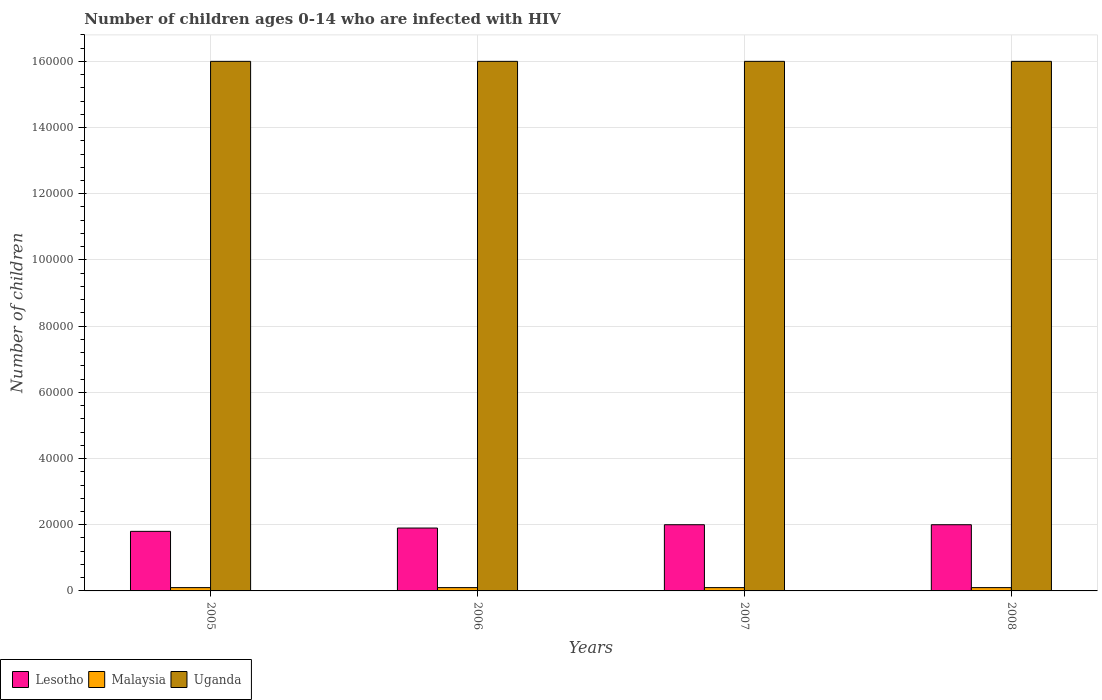How many different coloured bars are there?
Ensure brevity in your answer.  3. Are the number of bars on each tick of the X-axis equal?
Provide a short and direct response. Yes. How many bars are there on the 4th tick from the right?
Offer a very short reply. 3. What is the number of HIV infected children in Lesotho in 2006?
Make the answer very short. 1.90e+04. Across all years, what is the maximum number of HIV infected children in Lesotho?
Offer a terse response. 2.00e+04. Across all years, what is the minimum number of HIV infected children in Malaysia?
Provide a succinct answer. 1000. In which year was the number of HIV infected children in Malaysia minimum?
Your answer should be compact. 2005. What is the total number of HIV infected children in Malaysia in the graph?
Your answer should be very brief. 4000. What is the difference between the number of HIV infected children in Lesotho in 2005 and that in 2007?
Your answer should be compact. -2000. What is the difference between the number of HIV infected children in Malaysia in 2008 and the number of HIV infected children in Uganda in 2006?
Provide a succinct answer. -1.59e+05. In the year 2005, what is the difference between the number of HIV infected children in Malaysia and number of HIV infected children in Lesotho?
Offer a terse response. -1.70e+04. In how many years, is the number of HIV infected children in Uganda greater than 48000?
Offer a very short reply. 4. Is the number of HIV infected children in Lesotho in 2006 less than that in 2007?
Offer a terse response. Yes. Is the difference between the number of HIV infected children in Malaysia in 2005 and 2006 greater than the difference between the number of HIV infected children in Lesotho in 2005 and 2006?
Your response must be concise. Yes. What is the difference between the highest and the second highest number of HIV infected children in Uganda?
Ensure brevity in your answer.  0. What is the difference between the highest and the lowest number of HIV infected children in Malaysia?
Offer a terse response. 0. Is the sum of the number of HIV infected children in Uganda in 2005 and 2008 greater than the maximum number of HIV infected children in Malaysia across all years?
Give a very brief answer. Yes. What does the 2nd bar from the left in 2007 represents?
Provide a short and direct response. Malaysia. What does the 3rd bar from the right in 2008 represents?
Provide a short and direct response. Lesotho. Is it the case that in every year, the sum of the number of HIV infected children in Lesotho and number of HIV infected children in Uganda is greater than the number of HIV infected children in Malaysia?
Offer a terse response. Yes. Are the values on the major ticks of Y-axis written in scientific E-notation?
Your answer should be compact. No. Does the graph contain any zero values?
Provide a short and direct response. No. Where does the legend appear in the graph?
Make the answer very short. Bottom left. What is the title of the graph?
Make the answer very short. Number of children ages 0-14 who are infected with HIV. Does "Belarus" appear as one of the legend labels in the graph?
Keep it short and to the point. No. What is the label or title of the Y-axis?
Offer a very short reply. Number of children. What is the Number of children in Lesotho in 2005?
Your answer should be compact. 1.80e+04. What is the Number of children of Malaysia in 2005?
Keep it short and to the point. 1000. What is the Number of children in Uganda in 2005?
Provide a succinct answer. 1.60e+05. What is the Number of children in Lesotho in 2006?
Provide a succinct answer. 1.90e+04. What is the Number of children in Uganda in 2006?
Give a very brief answer. 1.60e+05. What is the Number of children of Uganda in 2007?
Provide a short and direct response. 1.60e+05. What is the Number of children of Malaysia in 2008?
Give a very brief answer. 1000. Across all years, what is the maximum Number of children of Malaysia?
Offer a terse response. 1000. Across all years, what is the minimum Number of children in Lesotho?
Make the answer very short. 1.80e+04. Across all years, what is the minimum Number of children of Malaysia?
Make the answer very short. 1000. What is the total Number of children in Lesotho in the graph?
Offer a terse response. 7.70e+04. What is the total Number of children in Malaysia in the graph?
Offer a very short reply. 4000. What is the total Number of children of Uganda in the graph?
Your answer should be compact. 6.40e+05. What is the difference between the Number of children of Lesotho in 2005 and that in 2006?
Give a very brief answer. -1000. What is the difference between the Number of children in Malaysia in 2005 and that in 2006?
Keep it short and to the point. 0. What is the difference between the Number of children of Uganda in 2005 and that in 2006?
Make the answer very short. 0. What is the difference between the Number of children in Lesotho in 2005 and that in 2007?
Provide a succinct answer. -2000. What is the difference between the Number of children in Uganda in 2005 and that in 2007?
Your answer should be compact. 0. What is the difference between the Number of children in Lesotho in 2005 and that in 2008?
Give a very brief answer. -2000. What is the difference between the Number of children in Lesotho in 2006 and that in 2007?
Your response must be concise. -1000. What is the difference between the Number of children in Lesotho in 2006 and that in 2008?
Your response must be concise. -1000. What is the difference between the Number of children in Malaysia in 2006 and that in 2008?
Keep it short and to the point. 0. What is the difference between the Number of children in Uganda in 2006 and that in 2008?
Make the answer very short. 0. What is the difference between the Number of children of Lesotho in 2007 and that in 2008?
Provide a succinct answer. 0. What is the difference between the Number of children in Uganda in 2007 and that in 2008?
Offer a very short reply. 0. What is the difference between the Number of children of Lesotho in 2005 and the Number of children of Malaysia in 2006?
Provide a succinct answer. 1.70e+04. What is the difference between the Number of children of Lesotho in 2005 and the Number of children of Uganda in 2006?
Your answer should be compact. -1.42e+05. What is the difference between the Number of children in Malaysia in 2005 and the Number of children in Uganda in 2006?
Offer a very short reply. -1.59e+05. What is the difference between the Number of children of Lesotho in 2005 and the Number of children of Malaysia in 2007?
Offer a very short reply. 1.70e+04. What is the difference between the Number of children in Lesotho in 2005 and the Number of children in Uganda in 2007?
Offer a terse response. -1.42e+05. What is the difference between the Number of children in Malaysia in 2005 and the Number of children in Uganda in 2007?
Make the answer very short. -1.59e+05. What is the difference between the Number of children of Lesotho in 2005 and the Number of children of Malaysia in 2008?
Keep it short and to the point. 1.70e+04. What is the difference between the Number of children of Lesotho in 2005 and the Number of children of Uganda in 2008?
Provide a succinct answer. -1.42e+05. What is the difference between the Number of children in Malaysia in 2005 and the Number of children in Uganda in 2008?
Give a very brief answer. -1.59e+05. What is the difference between the Number of children in Lesotho in 2006 and the Number of children in Malaysia in 2007?
Your response must be concise. 1.80e+04. What is the difference between the Number of children of Lesotho in 2006 and the Number of children of Uganda in 2007?
Ensure brevity in your answer.  -1.41e+05. What is the difference between the Number of children in Malaysia in 2006 and the Number of children in Uganda in 2007?
Your response must be concise. -1.59e+05. What is the difference between the Number of children in Lesotho in 2006 and the Number of children in Malaysia in 2008?
Your response must be concise. 1.80e+04. What is the difference between the Number of children of Lesotho in 2006 and the Number of children of Uganda in 2008?
Give a very brief answer. -1.41e+05. What is the difference between the Number of children of Malaysia in 2006 and the Number of children of Uganda in 2008?
Keep it short and to the point. -1.59e+05. What is the difference between the Number of children in Lesotho in 2007 and the Number of children in Malaysia in 2008?
Offer a terse response. 1.90e+04. What is the difference between the Number of children in Lesotho in 2007 and the Number of children in Uganda in 2008?
Your answer should be compact. -1.40e+05. What is the difference between the Number of children of Malaysia in 2007 and the Number of children of Uganda in 2008?
Ensure brevity in your answer.  -1.59e+05. What is the average Number of children of Lesotho per year?
Your answer should be compact. 1.92e+04. What is the average Number of children of Uganda per year?
Your response must be concise. 1.60e+05. In the year 2005, what is the difference between the Number of children in Lesotho and Number of children in Malaysia?
Your response must be concise. 1.70e+04. In the year 2005, what is the difference between the Number of children in Lesotho and Number of children in Uganda?
Provide a succinct answer. -1.42e+05. In the year 2005, what is the difference between the Number of children of Malaysia and Number of children of Uganda?
Offer a very short reply. -1.59e+05. In the year 2006, what is the difference between the Number of children in Lesotho and Number of children in Malaysia?
Keep it short and to the point. 1.80e+04. In the year 2006, what is the difference between the Number of children in Lesotho and Number of children in Uganda?
Offer a terse response. -1.41e+05. In the year 2006, what is the difference between the Number of children in Malaysia and Number of children in Uganda?
Give a very brief answer. -1.59e+05. In the year 2007, what is the difference between the Number of children of Lesotho and Number of children of Malaysia?
Give a very brief answer. 1.90e+04. In the year 2007, what is the difference between the Number of children in Lesotho and Number of children in Uganda?
Give a very brief answer. -1.40e+05. In the year 2007, what is the difference between the Number of children in Malaysia and Number of children in Uganda?
Make the answer very short. -1.59e+05. In the year 2008, what is the difference between the Number of children in Lesotho and Number of children in Malaysia?
Offer a terse response. 1.90e+04. In the year 2008, what is the difference between the Number of children of Lesotho and Number of children of Uganda?
Ensure brevity in your answer.  -1.40e+05. In the year 2008, what is the difference between the Number of children in Malaysia and Number of children in Uganda?
Keep it short and to the point. -1.59e+05. What is the ratio of the Number of children in Uganda in 2005 to that in 2006?
Offer a terse response. 1. What is the ratio of the Number of children in Uganda in 2005 to that in 2007?
Provide a short and direct response. 1. What is the ratio of the Number of children in Lesotho in 2005 to that in 2008?
Provide a short and direct response. 0.9. What is the ratio of the Number of children in Malaysia in 2005 to that in 2008?
Your answer should be very brief. 1. What is the ratio of the Number of children in Uganda in 2005 to that in 2008?
Your answer should be compact. 1. What is the ratio of the Number of children in Lesotho in 2006 to that in 2007?
Your response must be concise. 0.95. What is the ratio of the Number of children in Malaysia in 2006 to that in 2007?
Your answer should be compact. 1. What is the ratio of the Number of children of Uganda in 2006 to that in 2007?
Ensure brevity in your answer.  1. What is the ratio of the Number of children in Lesotho in 2006 to that in 2008?
Your answer should be very brief. 0.95. What is the ratio of the Number of children in Malaysia in 2006 to that in 2008?
Your response must be concise. 1. What is the ratio of the Number of children of Lesotho in 2007 to that in 2008?
Offer a terse response. 1. What is the ratio of the Number of children in Malaysia in 2007 to that in 2008?
Ensure brevity in your answer.  1. What is the ratio of the Number of children in Uganda in 2007 to that in 2008?
Your answer should be very brief. 1. What is the difference between the highest and the second highest Number of children of Lesotho?
Provide a short and direct response. 0. What is the difference between the highest and the lowest Number of children in Lesotho?
Provide a succinct answer. 2000. What is the difference between the highest and the lowest Number of children in Uganda?
Give a very brief answer. 0. 